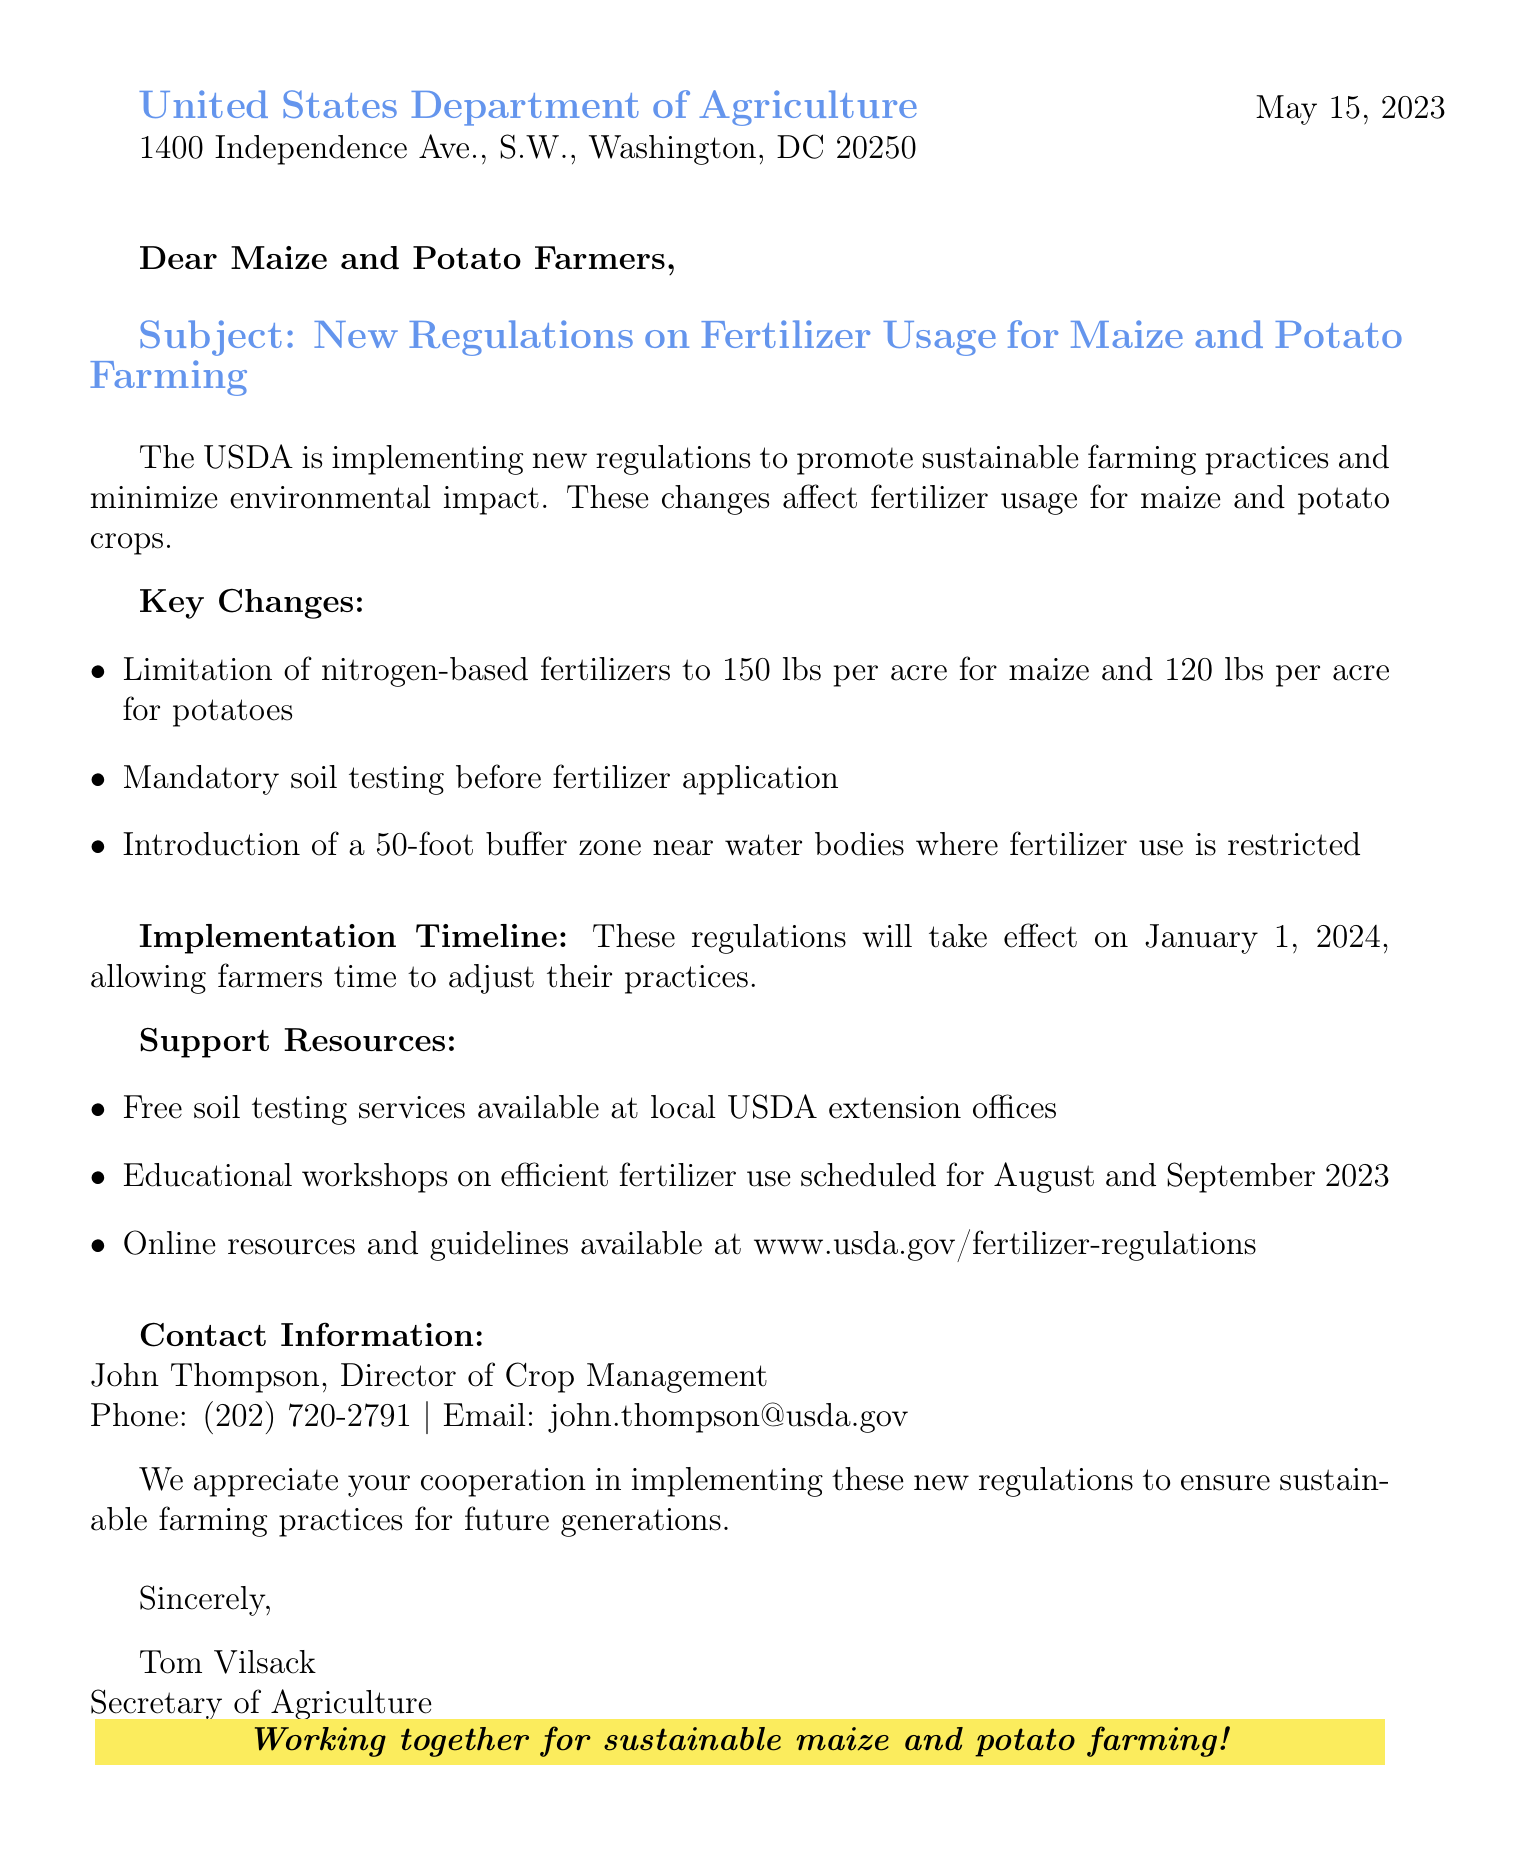What is the date of the letter? The letter is dated May 15, 2023.
Answer: May 15, 2023 Who is the Director of Crop Management? The Director of Crop Management mentioned in the document is John Thompson.
Answer: John Thompson What is the maximum nitrogen fertilizer limit for maize per acre? The letter states that the limitation is 150 lbs per acre for maize.
Answer: 150 lbs What resource is available for free soil testing? The document mentions free soil testing services available at local USDA extension offices.
Answer: Local USDA extension offices What is the effective date for the new regulations? The regulations will take effect on January 1, 2024.
Answer: January 1, 2024 How many lbs of nitrogen fertilizer can potatoes have per acre? The letter specifies the limit for potatoes as 120 lbs per acre.
Answer: 120 lbs What workshops are scheduled for August and September 2023? The letter mentions educational workshops on efficient fertilizer use.
Answer: Educational workshops What is the purpose of the new regulations? The purpose is to promote sustainable farming practices and minimize environmental impact.
Answer: Sustainable farming practices Is there a buffer zone near water bodies? Yes, a 50-foot buffer zone is mentioned where fertilizer use is restricted.
Answer: 50-foot buffer zone 